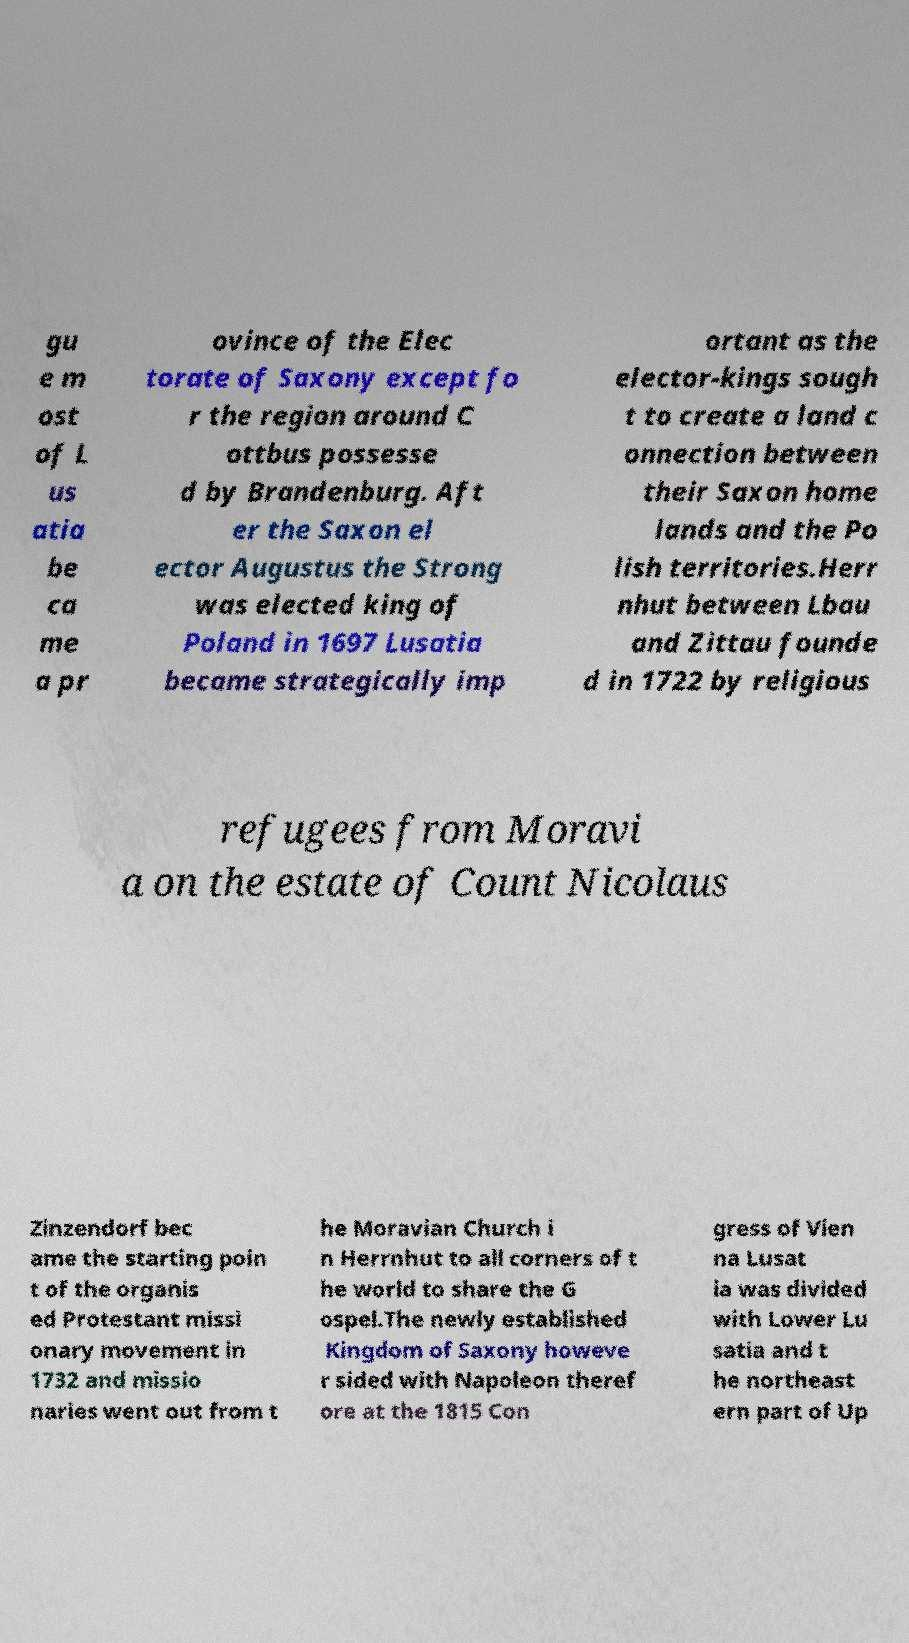Could you extract and type out the text from this image? gu e m ost of L us atia be ca me a pr ovince of the Elec torate of Saxony except fo r the region around C ottbus possesse d by Brandenburg. Aft er the Saxon el ector Augustus the Strong was elected king of Poland in 1697 Lusatia became strategically imp ortant as the elector-kings sough t to create a land c onnection between their Saxon home lands and the Po lish territories.Herr nhut between Lbau and Zittau founde d in 1722 by religious refugees from Moravi a on the estate of Count Nicolaus Zinzendorf bec ame the starting poin t of the organis ed Protestant missi onary movement in 1732 and missio naries went out from t he Moravian Church i n Herrnhut to all corners of t he world to share the G ospel.The newly established Kingdom of Saxony howeve r sided with Napoleon theref ore at the 1815 Con gress of Vien na Lusat ia was divided with Lower Lu satia and t he northeast ern part of Up 